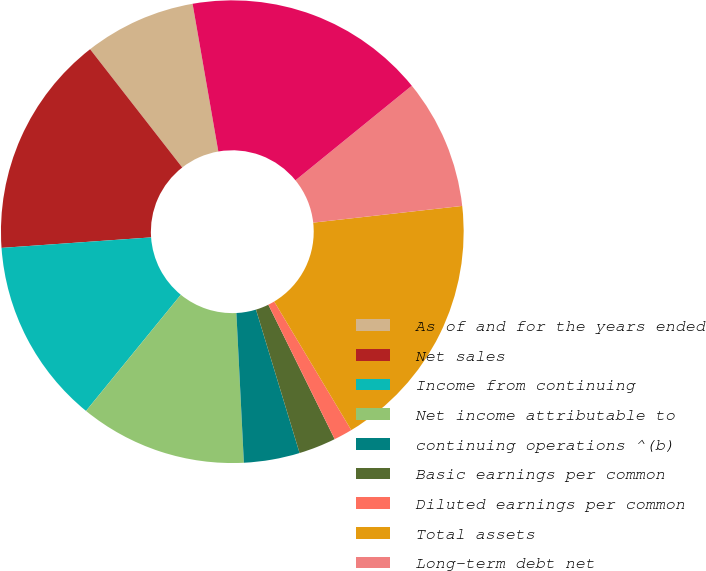Convert chart to OTSL. <chart><loc_0><loc_0><loc_500><loc_500><pie_chart><fcel>As of and for the years ended<fcel>Net sales<fcel>Income from continuing<fcel>Net income attributable to<fcel>continuing operations ^(b)<fcel>Basic earnings per common<fcel>Diluted earnings per common<fcel>Total assets<fcel>Long-term debt net<fcel>Stockholders' equity<nl><fcel>7.79%<fcel>15.58%<fcel>12.99%<fcel>11.69%<fcel>3.9%<fcel>2.6%<fcel>1.3%<fcel>18.18%<fcel>9.09%<fcel>16.88%<nl></chart> 